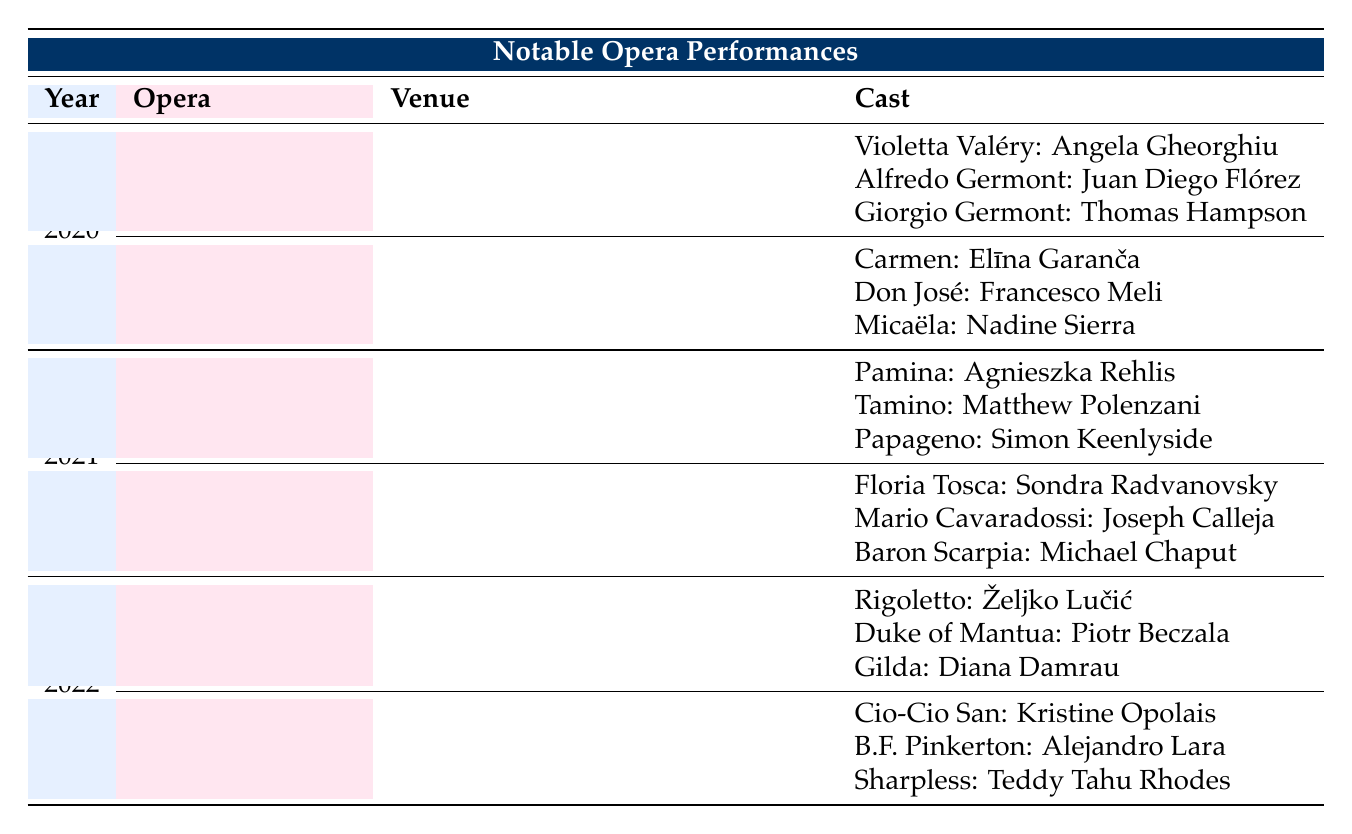What was the venue for "La Traviata" in 2020? Referring to the table, "La Traviata" was performed at "Teatro alla Scala, Milan" in 2020.
Answer: Teatro alla Scala, Milan Who performed the role of Carmen in 2020? The table indicates that Elīna Garanča performed the role of Carmen in the year 2020.
Answer: Elīna Garanča How many different operas were performed in 2021? In 2021, there were two operas listed: "The Magic Flute" and "Tosca." Therefore, the total count is 2.
Answer: 2 Did Sondra Radvanovsky perform in 2020? By checking the table, Sondra Radvanovsky is listed as performing in "Tosca" in 2021, and there’s no mention of her in 2020. Thus, the answer is no.
Answer: No Which opera had the performer Željko Lučić in 2022, and what was his role? Looking at the table for 2022, Željko Lučić performed in "Rigoletto" as the title character, Rigoletto.
Answer: Rigoletto, Rigoletto What is the total number of performers listed for "Carmen" in 2020? The table lists three performers for "Carmen": Elīna Garanča, Francesco Meli, and Nadine Sierra. Adding these gives a total of 3 performers.
Answer: 3 Which venue hosted "Madama Butterfly" in 2022? According to the table, "Madama Butterfly" was performed at the "Sydney Opera House, Sydney" in 2022.
Answer: Sydney Opera House, Sydney In terms of venue, which opera was performed at the Metropolitan Opera in 2021? Looking at the table, the opera performed at the Metropolitan Opera in 2021 was "The Magic Flute."
Answer: The Magic Flute List all the roles performed by Angela Gheorghiu. Angela Gheorghiu performed the role of Violetta Valéry in "La Traviata" in 2020. She is not associated with any other roles in this table. The answer lists 1 role.
Answer: Violetta Valéry 